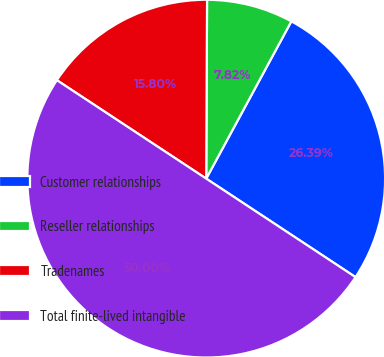<chart> <loc_0><loc_0><loc_500><loc_500><pie_chart><fcel>Customer relationships<fcel>Reseller relationships<fcel>Tradenames<fcel>Total finite-lived intangible<nl><fcel>26.39%<fcel>7.82%<fcel>15.8%<fcel>50.0%<nl></chart> 